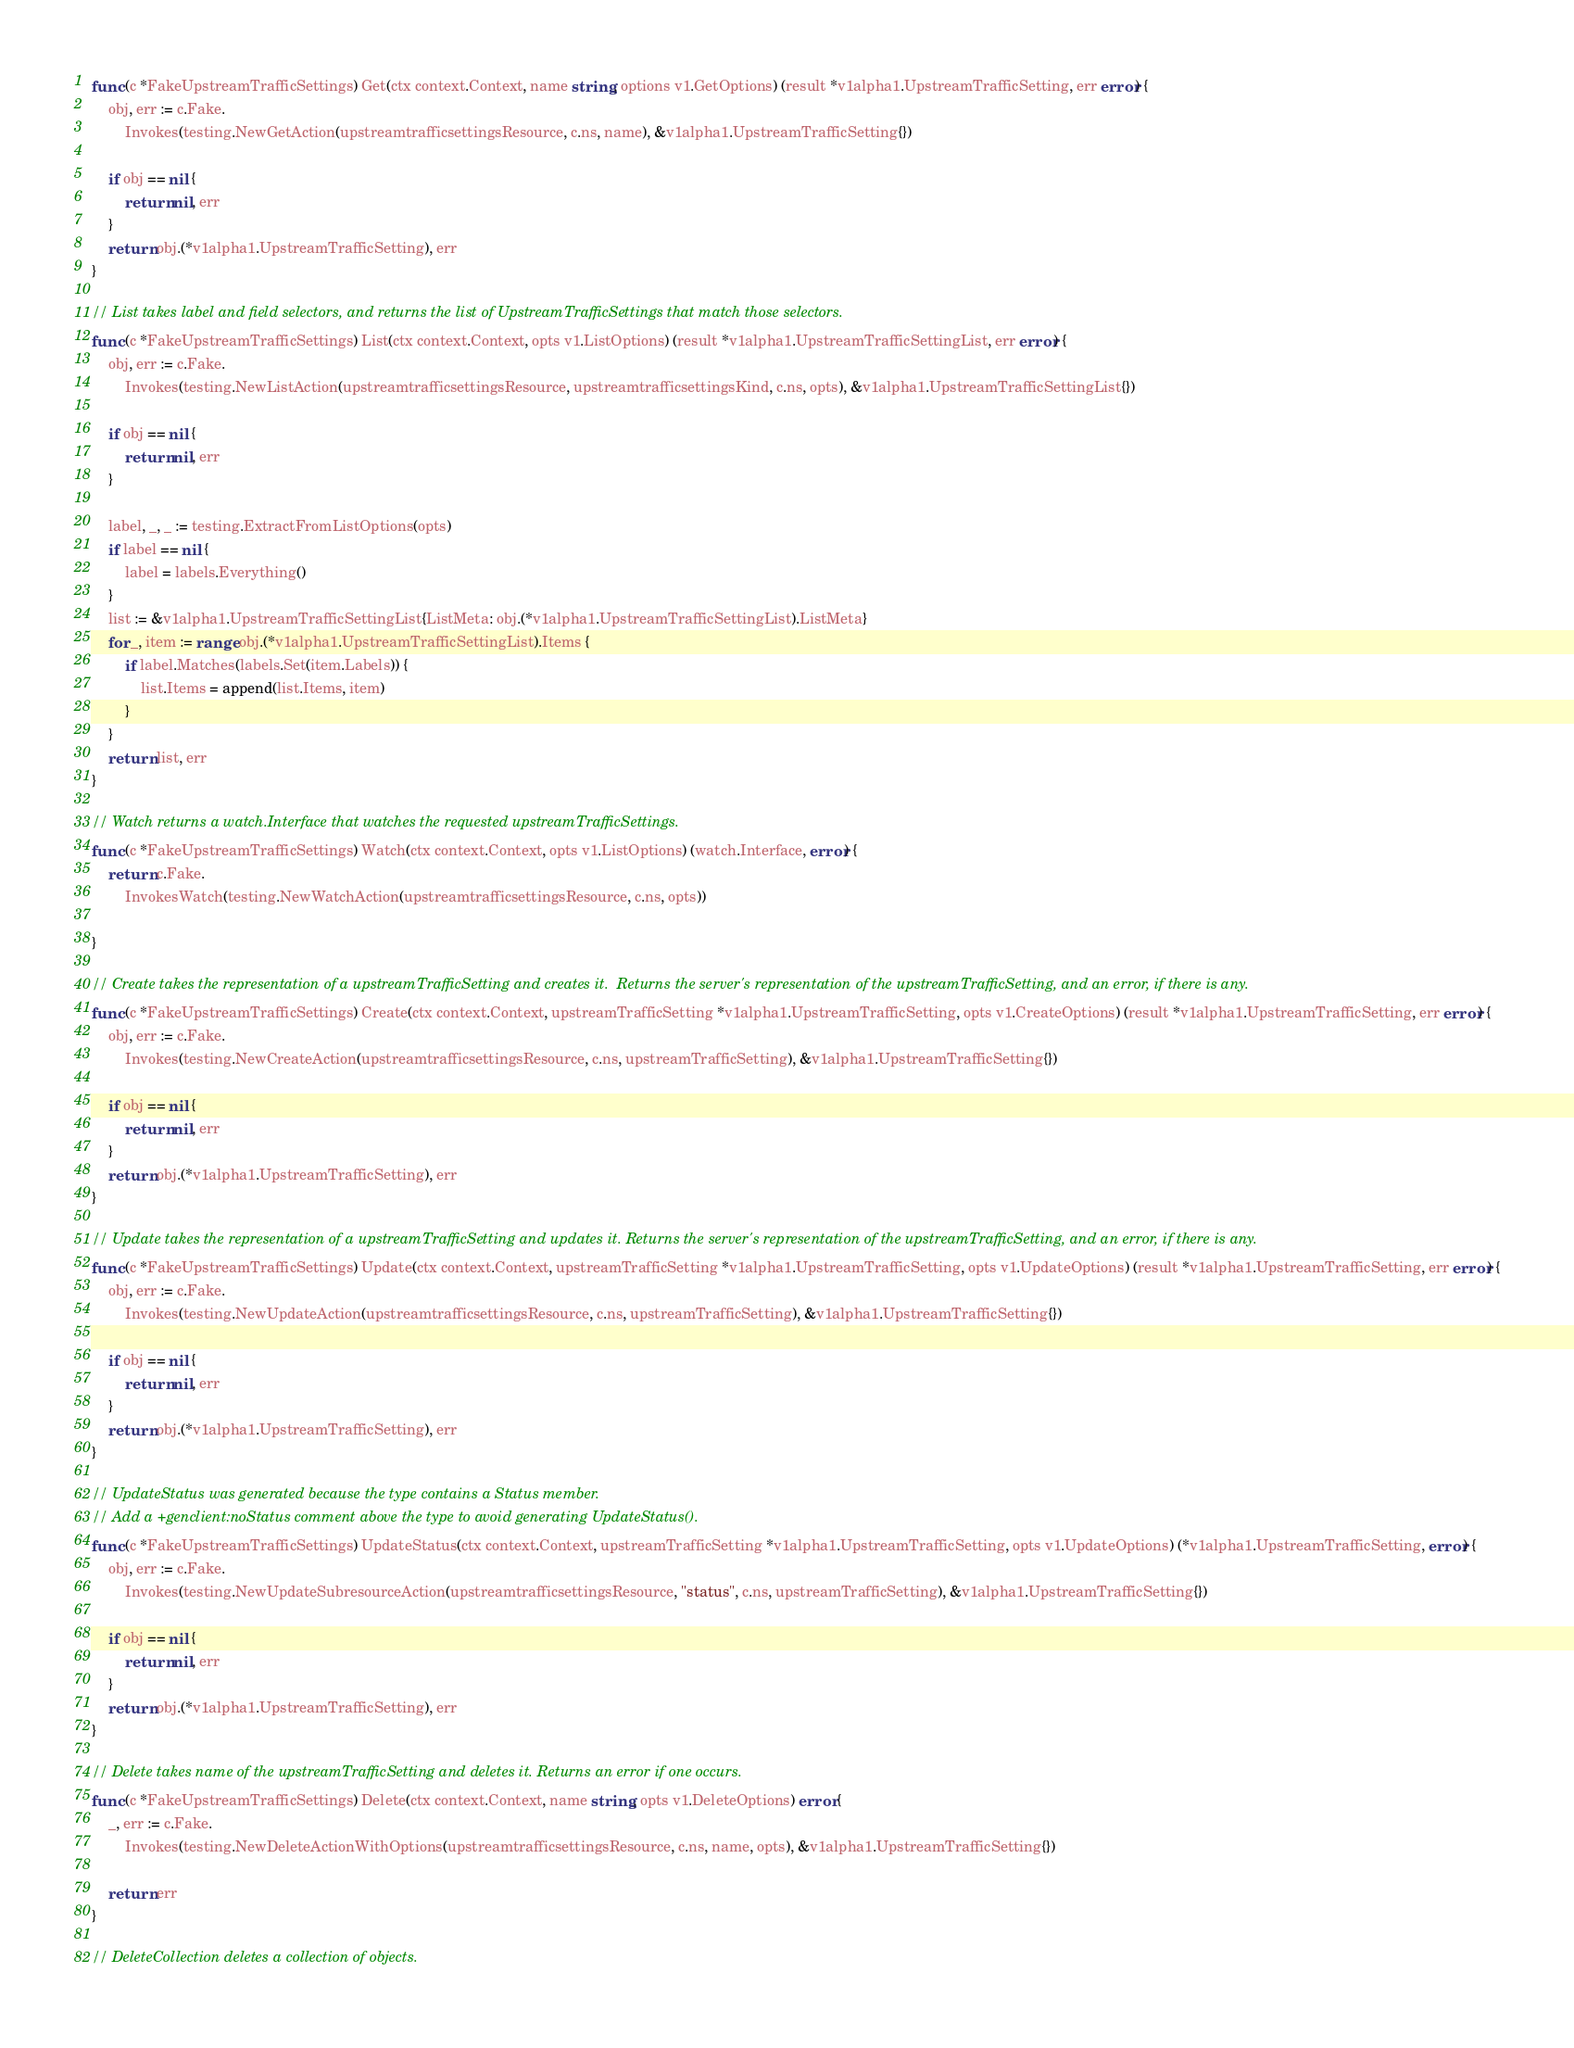<code> <loc_0><loc_0><loc_500><loc_500><_Go_>func (c *FakeUpstreamTrafficSettings) Get(ctx context.Context, name string, options v1.GetOptions) (result *v1alpha1.UpstreamTrafficSetting, err error) {
	obj, err := c.Fake.
		Invokes(testing.NewGetAction(upstreamtrafficsettingsResource, c.ns, name), &v1alpha1.UpstreamTrafficSetting{})

	if obj == nil {
		return nil, err
	}
	return obj.(*v1alpha1.UpstreamTrafficSetting), err
}

// List takes label and field selectors, and returns the list of UpstreamTrafficSettings that match those selectors.
func (c *FakeUpstreamTrafficSettings) List(ctx context.Context, opts v1.ListOptions) (result *v1alpha1.UpstreamTrafficSettingList, err error) {
	obj, err := c.Fake.
		Invokes(testing.NewListAction(upstreamtrafficsettingsResource, upstreamtrafficsettingsKind, c.ns, opts), &v1alpha1.UpstreamTrafficSettingList{})

	if obj == nil {
		return nil, err
	}

	label, _, _ := testing.ExtractFromListOptions(opts)
	if label == nil {
		label = labels.Everything()
	}
	list := &v1alpha1.UpstreamTrafficSettingList{ListMeta: obj.(*v1alpha1.UpstreamTrafficSettingList).ListMeta}
	for _, item := range obj.(*v1alpha1.UpstreamTrafficSettingList).Items {
		if label.Matches(labels.Set(item.Labels)) {
			list.Items = append(list.Items, item)
		}
	}
	return list, err
}

// Watch returns a watch.Interface that watches the requested upstreamTrafficSettings.
func (c *FakeUpstreamTrafficSettings) Watch(ctx context.Context, opts v1.ListOptions) (watch.Interface, error) {
	return c.Fake.
		InvokesWatch(testing.NewWatchAction(upstreamtrafficsettingsResource, c.ns, opts))

}

// Create takes the representation of a upstreamTrafficSetting and creates it.  Returns the server's representation of the upstreamTrafficSetting, and an error, if there is any.
func (c *FakeUpstreamTrafficSettings) Create(ctx context.Context, upstreamTrafficSetting *v1alpha1.UpstreamTrafficSetting, opts v1.CreateOptions) (result *v1alpha1.UpstreamTrafficSetting, err error) {
	obj, err := c.Fake.
		Invokes(testing.NewCreateAction(upstreamtrafficsettingsResource, c.ns, upstreamTrafficSetting), &v1alpha1.UpstreamTrafficSetting{})

	if obj == nil {
		return nil, err
	}
	return obj.(*v1alpha1.UpstreamTrafficSetting), err
}

// Update takes the representation of a upstreamTrafficSetting and updates it. Returns the server's representation of the upstreamTrafficSetting, and an error, if there is any.
func (c *FakeUpstreamTrafficSettings) Update(ctx context.Context, upstreamTrafficSetting *v1alpha1.UpstreamTrafficSetting, opts v1.UpdateOptions) (result *v1alpha1.UpstreamTrafficSetting, err error) {
	obj, err := c.Fake.
		Invokes(testing.NewUpdateAction(upstreamtrafficsettingsResource, c.ns, upstreamTrafficSetting), &v1alpha1.UpstreamTrafficSetting{})

	if obj == nil {
		return nil, err
	}
	return obj.(*v1alpha1.UpstreamTrafficSetting), err
}

// UpdateStatus was generated because the type contains a Status member.
// Add a +genclient:noStatus comment above the type to avoid generating UpdateStatus().
func (c *FakeUpstreamTrafficSettings) UpdateStatus(ctx context.Context, upstreamTrafficSetting *v1alpha1.UpstreamTrafficSetting, opts v1.UpdateOptions) (*v1alpha1.UpstreamTrafficSetting, error) {
	obj, err := c.Fake.
		Invokes(testing.NewUpdateSubresourceAction(upstreamtrafficsettingsResource, "status", c.ns, upstreamTrafficSetting), &v1alpha1.UpstreamTrafficSetting{})

	if obj == nil {
		return nil, err
	}
	return obj.(*v1alpha1.UpstreamTrafficSetting), err
}

// Delete takes name of the upstreamTrafficSetting and deletes it. Returns an error if one occurs.
func (c *FakeUpstreamTrafficSettings) Delete(ctx context.Context, name string, opts v1.DeleteOptions) error {
	_, err := c.Fake.
		Invokes(testing.NewDeleteActionWithOptions(upstreamtrafficsettingsResource, c.ns, name, opts), &v1alpha1.UpstreamTrafficSetting{})

	return err
}

// DeleteCollection deletes a collection of objects.</code> 